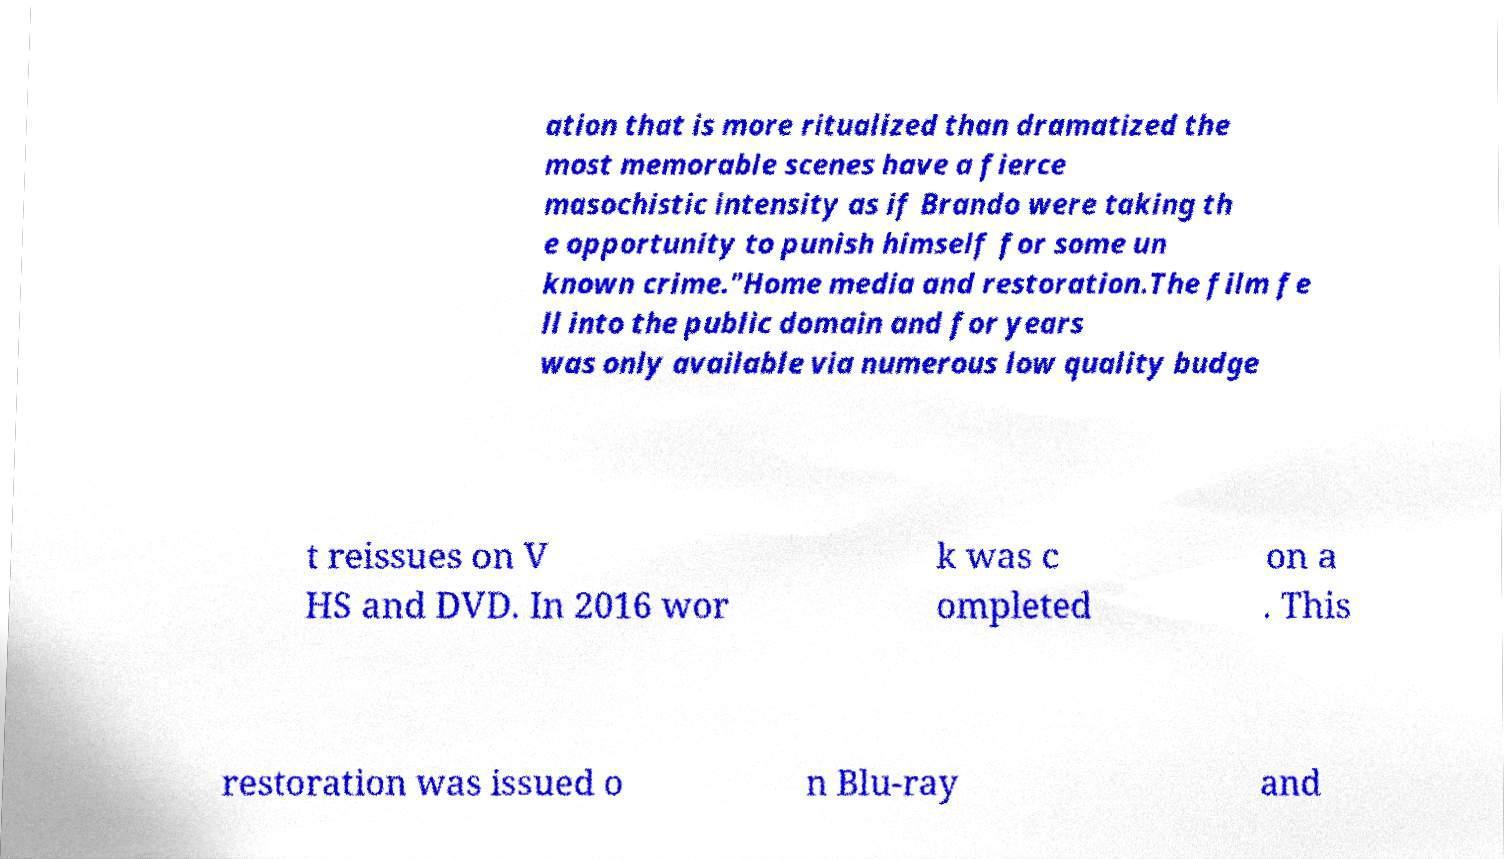Can you read and provide the text displayed in the image?This photo seems to have some interesting text. Can you extract and type it out for me? ation that is more ritualized than dramatized the most memorable scenes have a fierce masochistic intensity as if Brando were taking th e opportunity to punish himself for some un known crime."Home media and restoration.The film fe ll into the public domain and for years was only available via numerous low quality budge t reissues on V HS and DVD. In 2016 wor k was c ompleted on a . This restoration was issued o n Blu-ray and 